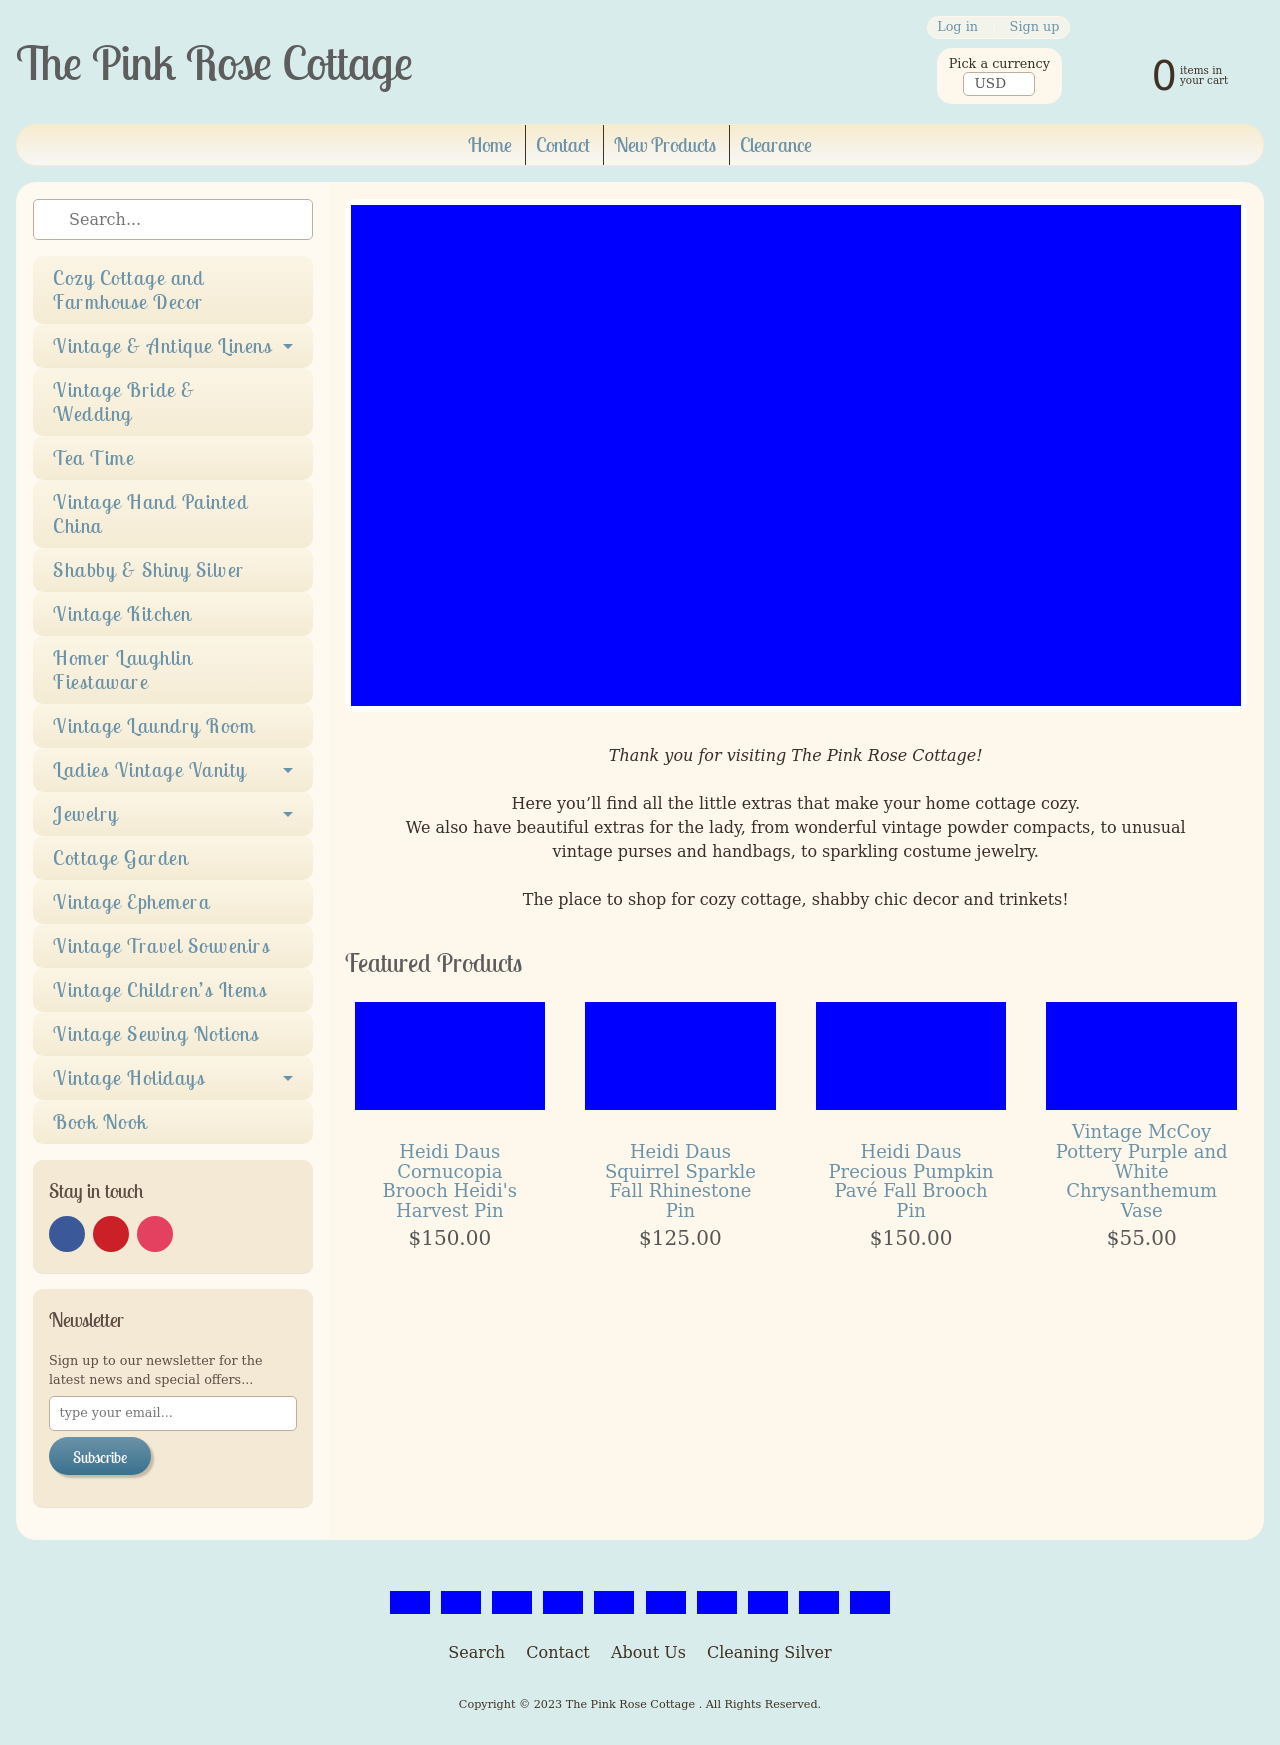How can I start building this website with HTML from the ground up? To start building a website like The Pink Rose Cottage with HTML, begin with the basic structure including <!DOCTYPE html>, <html>, <head>, and <body> tags. Define the character set with <meta charset="utf-8"> and ensure your website is responsive by including a viewport meta tag. Pour in elements within the <body> to match sections such as header, navigation menu, main content area, and footer. Utilize CSS for styling, focusing on the website's aesthetic that complements the vintage cozy theme. Add interactivity with JavaScript if necessary. From there, you can populate the body with images, descriptions, and links particular to your categories like 'Vintage Kitchen' or 'Cottage Garden'. Importantly, remember to regularly test your website across different browsers and devices. 